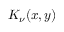<formula> <loc_0><loc_0><loc_500><loc_500>K _ { \nu } ( x , y )</formula> 